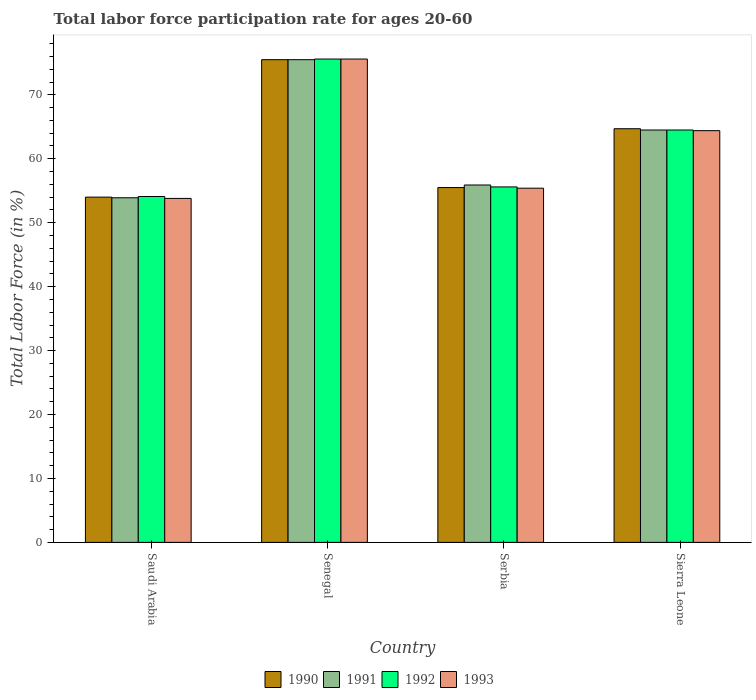How many different coloured bars are there?
Ensure brevity in your answer.  4. How many bars are there on the 1st tick from the right?
Make the answer very short. 4. What is the label of the 3rd group of bars from the left?
Give a very brief answer. Serbia. Across all countries, what is the maximum labor force participation rate in 1991?
Provide a succinct answer. 75.5. Across all countries, what is the minimum labor force participation rate in 1992?
Give a very brief answer. 54.1. In which country was the labor force participation rate in 1992 maximum?
Your answer should be compact. Senegal. In which country was the labor force participation rate in 1990 minimum?
Your response must be concise. Saudi Arabia. What is the total labor force participation rate in 1990 in the graph?
Your answer should be very brief. 249.7. What is the difference between the labor force participation rate in 1993 in Senegal and that in Serbia?
Your answer should be very brief. 20.2. What is the difference between the labor force participation rate in 1991 in Saudi Arabia and the labor force participation rate in 1993 in Sierra Leone?
Your answer should be compact. -10.5. What is the average labor force participation rate in 1993 per country?
Provide a short and direct response. 62.3. What is the difference between the labor force participation rate of/in 1992 and labor force participation rate of/in 1990 in Serbia?
Provide a succinct answer. 0.1. In how many countries, is the labor force participation rate in 1993 greater than 14 %?
Your answer should be very brief. 4. What is the ratio of the labor force participation rate in 1991 in Serbia to that in Sierra Leone?
Give a very brief answer. 0.87. Is the labor force participation rate in 1993 in Serbia less than that in Sierra Leone?
Offer a very short reply. Yes. What is the difference between the highest and the second highest labor force participation rate in 1992?
Offer a very short reply. -11.1. What is the difference between the highest and the lowest labor force participation rate in 1991?
Make the answer very short. 21.6. Is the sum of the labor force participation rate in 1993 in Saudi Arabia and Serbia greater than the maximum labor force participation rate in 1990 across all countries?
Give a very brief answer. Yes. Is it the case that in every country, the sum of the labor force participation rate in 1991 and labor force participation rate in 1993 is greater than the sum of labor force participation rate in 1990 and labor force participation rate in 1992?
Your answer should be compact. No. What does the 2nd bar from the left in Serbia represents?
Give a very brief answer. 1991. What does the 2nd bar from the right in Sierra Leone represents?
Provide a short and direct response. 1992. Is it the case that in every country, the sum of the labor force participation rate in 1990 and labor force participation rate in 1993 is greater than the labor force participation rate in 1991?
Make the answer very short. Yes. How many countries are there in the graph?
Keep it short and to the point. 4. What is the difference between two consecutive major ticks on the Y-axis?
Keep it short and to the point. 10. Are the values on the major ticks of Y-axis written in scientific E-notation?
Provide a succinct answer. No. Does the graph contain any zero values?
Your response must be concise. No. Does the graph contain grids?
Provide a succinct answer. No. What is the title of the graph?
Offer a very short reply. Total labor force participation rate for ages 20-60. What is the label or title of the X-axis?
Keep it short and to the point. Country. What is the label or title of the Y-axis?
Your response must be concise. Total Labor Force (in %). What is the Total Labor Force (in %) in 1991 in Saudi Arabia?
Offer a very short reply. 53.9. What is the Total Labor Force (in %) in 1992 in Saudi Arabia?
Give a very brief answer. 54.1. What is the Total Labor Force (in %) in 1993 in Saudi Arabia?
Keep it short and to the point. 53.8. What is the Total Labor Force (in %) of 1990 in Senegal?
Make the answer very short. 75.5. What is the Total Labor Force (in %) of 1991 in Senegal?
Give a very brief answer. 75.5. What is the Total Labor Force (in %) of 1992 in Senegal?
Your answer should be compact. 75.6. What is the Total Labor Force (in %) in 1993 in Senegal?
Offer a terse response. 75.6. What is the Total Labor Force (in %) in 1990 in Serbia?
Your response must be concise. 55.5. What is the Total Labor Force (in %) of 1991 in Serbia?
Make the answer very short. 55.9. What is the Total Labor Force (in %) of 1992 in Serbia?
Give a very brief answer. 55.6. What is the Total Labor Force (in %) in 1993 in Serbia?
Offer a terse response. 55.4. What is the Total Labor Force (in %) in 1990 in Sierra Leone?
Your answer should be very brief. 64.7. What is the Total Labor Force (in %) in 1991 in Sierra Leone?
Offer a terse response. 64.5. What is the Total Labor Force (in %) in 1992 in Sierra Leone?
Your answer should be very brief. 64.5. What is the Total Labor Force (in %) in 1993 in Sierra Leone?
Your response must be concise. 64.4. Across all countries, what is the maximum Total Labor Force (in %) of 1990?
Offer a terse response. 75.5. Across all countries, what is the maximum Total Labor Force (in %) in 1991?
Your answer should be compact. 75.5. Across all countries, what is the maximum Total Labor Force (in %) of 1992?
Offer a very short reply. 75.6. Across all countries, what is the maximum Total Labor Force (in %) in 1993?
Your answer should be compact. 75.6. Across all countries, what is the minimum Total Labor Force (in %) of 1990?
Your response must be concise. 54. Across all countries, what is the minimum Total Labor Force (in %) in 1991?
Keep it short and to the point. 53.9. Across all countries, what is the minimum Total Labor Force (in %) of 1992?
Give a very brief answer. 54.1. Across all countries, what is the minimum Total Labor Force (in %) in 1993?
Provide a succinct answer. 53.8. What is the total Total Labor Force (in %) in 1990 in the graph?
Keep it short and to the point. 249.7. What is the total Total Labor Force (in %) of 1991 in the graph?
Make the answer very short. 249.8. What is the total Total Labor Force (in %) in 1992 in the graph?
Your response must be concise. 249.8. What is the total Total Labor Force (in %) in 1993 in the graph?
Your response must be concise. 249.2. What is the difference between the Total Labor Force (in %) in 1990 in Saudi Arabia and that in Senegal?
Your response must be concise. -21.5. What is the difference between the Total Labor Force (in %) of 1991 in Saudi Arabia and that in Senegal?
Offer a very short reply. -21.6. What is the difference between the Total Labor Force (in %) in 1992 in Saudi Arabia and that in Senegal?
Your answer should be compact. -21.5. What is the difference between the Total Labor Force (in %) in 1993 in Saudi Arabia and that in Senegal?
Provide a succinct answer. -21.8. What is the difference between the Total Labor Force (in %) of 1992 in Saudi Arabia and that in Serbia?
Give a very brief answer. -1.5. What is the difference between the Total Labor Force (in %) of 1993 in Saudi Arabia and that in Serbia?
Give a very brief answer. -1.6. What is the difference between the Total Labor Force (in %) in 1990 in Saudi Arabia and that in Sierra Leone?
Make the answer very short. -10.7. What is the difference between the Total Labor Force (in %) of 1992 in Saudi Arabia and that in Sierra Leone?
Provide a succinct answer. -10.4. What is the difference between the Total Labor Force (in %) in 1990 in Senegal and that in Serbia?
Your answer should be compact. 20. What is the difference between the Total Labor Force (in %) in 1991 in Senegal and that in Serbia?
Keep it short and to the point. 19.6. What is the difference between the Total Labor Force (in %) of 1992 in Senegal and that in Serbia?
Keep it short and to the point. 20. What is the difference between the Total Labor Force (in %) in 1993 in Senegal and that in Serbia?
Ensure brevity in your answer.  20.2. What is the difference between the Total Labor Force (in %) in 1990 in Senegal and that in Sierra Leone?
Offer a very short reply. 10.8. What is the difference between the Total Labor Force (in %) of 1992 in Senegal and that in Sierra Leone?
Offer a terse response. 11.1. What is the difference between the Total Labor Force (in %) of 1991 in Serbia and that in Sierra Leone?
Offer a terse response. -8.6. What is the difference between the Total Labor Force (in %) of 1992 in Serbia and that in Sierra Leone?
Your answer should be compact. -8.9. What is the difference between the Total Labor Force (in %) of 1993 in Serbia and that in Sierra Leone?
Keep it short and to the point. -9. What is the difference between the Total Labor Force (in %) in 1990 in Saudi Arabia and the Total Labor Force (in %) in 1991 in Senegal?
Give a very brief answer. -21.5. What is the difference between the Total Labor Force (in %) in 1990 in Saudi Arabia and the Total Labor Force (in %) in 1992 in Senegal?
Ensure brevity in your answer.  -21.6. What is the difference between the Total Labor Force (in %) of 1990 in Saudi Arabia and the Total Labor Force (in %) of 1993 in Senegal?
Give a very brief answer. -21.6. What is the difference between the Total Labor Force (in %) in 1991 in Saudi Arabia and the Total Labor Force (in %) in 1992 in Senegal?
Ensure brevity in your answer.  -21.7. What is the difference between the Total Labor Force (in %) in 1991 in Saudi Arabia and the Total Labor Force (in %) in 1993 in Senegal?
Your response must be concise. -21.7. What is the difference between the Total Labor Force (in %) in 1992 in Saudi Arabia and the Total Labor Force (in %) in 1993 in Senegal?
Your response must be concise. -21.5. What is the difference between the Total Labor Force (in %) in 1990 in Saudi Arabia and the Total Labor Force (in %) in 1992 in Serbia?
Your answer should be compact. -1.6. What is the difference between the Total Labor Force (in %) in 1990 in Saudi Arabia and the Total Labor Force (in %) in 1993 in Serbia?
Keep it short and to the point. -1.4. What is the difference between the Total Labor Force (in %) of 1991 in Saudi Arabia and the Total Labor Force (in %) of 1993 in Serbia?
Your response must be concise. -1.5. What is the difference between the Total Labor Force (in %) of 1992 in Saudi Arabia and the Total Labor Force (in %) of 1993 in Serbia?
Give a very brief answer. -1.3. What is the difference between the Total Labor Force (in %) in 1990 in Saudi Arabia and the Total Labor Force (in %) in 1993 in Sierra Leone?
Provide a short and direct response. -10.4. What is the difference between the Total Labor Force (in %) of 1991 in Saudi Arabia and the Total Labor Force (in %) of 1992 in Sierra Leone?
Offer a terse response. -10.6. What is the difference between the Total Labor Force (in %) of 1992 in Saudi Arabia and the Total Labor Force (in %) of 1993 in Sierra Leone?
Your answer should be compact. -10.3. What is the difference between the Total Labor Force (in %) in 1990 in Senegal and the Total Labor Force (in %) in 1991 in Serbia?
Offer a terse response. 19.6. What is the difference between the Total Labor Force (in %) of 1990 in Senegal and the Total Labor Force (in %) of 1993 in Serbia?
Provide a short and direct response. 20.1. What is the difference between the Total Labor Force (in %) of 1991 in Senegal and the Total Labor Force (in %) of 1993 in Serbia?
Keep it short and to the point. 20.1. What is the difference between the Total Labor Force (in %) in 1992 in Senegal and the Total Labor Force (in %) in 1993 in Serbia?
Your response must be concise. 20.2. What is the difference between the Total Labor Force (in %) of 1990 in Senegal and the Total Labor Force (in %) of 1991 in Sierra Leone?
Keep it short and to the point. 11. What is the difference between the Total Labor Force (in %) in 1991 in Senegal and the Total Labor Force (in %) in 1993 in Sierra Leone?
Your answer should be compact. 11.1. What is the difference between the Total Labor Force (in %) in 1990 in Serbia and the Total Labor Force (in %) in 1993 in Sierra Leone?
Offer a terse response. -8.9. What is the difference between the Total Labor Force (in %) of 1991 in Serbia and the Total Labor Force (in %) of 1992 in Sierra Leone?
Provide a succinct answer. -8.6. What is the average Total Labor Force (in %) in 1990 per country?
Your answer should be compact. 62.42. What is the average Total Labor Force (in %) in 1991 per country?
Give a very brief answer. 62.45. What is the average Total Labor Force (in %) in 1992 per country?
Offer a very short reply. 62.45. What is the average Total Labor Force (in %) in 1993 per country?
Make the answer very short. 62.3. What is the difference between the Total Labor Force (in %) in 1990 and Total Labor Force (in %) in 1991 in Saudi Arabia?
Give a very brief answer. 0.1. What is the difference between the Total Labor Force (in %) of 1990 and Total Labor Force (in %) of 1992 in Saudi Arabia?
Offer a terse response. -0.1. What is the difference between the Total Labor Force (in %) of 1990 and Total Labor Force (in %) of 1993 in Saudi Arabia?
Provide a short and direct response. 0.2. What is the difference between the Total Labor Force (in %) of 1991 and Total Labor Force (in %) of 1993 in Saudi Arabia?
Offer a very short reply. 0.1. What is the difference between the Total Labor Force (in %) of 1990 and Total Labor Force (in %) of 1991 in Senegal?
Give a very brief answer. 0. What is the difference between the Total Labor Force (in %) in 1992 and Total Labor Force (in %) in 1993 in Senegal?
Your answer should be very brief. 0. What is the difference between the Total Labor Force (in %) of 1990 and Total Labor Force (in %) of 1991 in Serbia?
Offer a very short reply. -0.4. What is the difference between the Total Labor Force (in %) in 1990 and Total Labor Force (in %) in 1992 in Serbia?
Give a very brief answer. -0.1. What is the difference between the Total Labor Force (in %) of 1990 and Total Labor Force (in %) of 1993 in Serbia?
Offer a very short reply. 0.1. What is the difference between the Total Labor Force (in %) in 1991 and Total Labor Force (in %) in 1992 in Serbia?
Provide a short and direct response. 0.3. What is the difference between the Total Labor Force (in %) of 1991 and Total Labor Force (in %) of 1993 in Serbia?
Ensure brevity in your answer.  0.5. What is the difference between the Total Labor Force (in %) in 1992 and Total Labor Force (in %) in 1993 in Serbia?
Provide a short and direct response. 0.2. What is the difference between the Total Labor Force (in %) in 1990 and Total Labor Force (in %) in 1992 in Sierra Leone?
Your response must be concise. 0.2. What is the difference between the Total Labor Force (in %) in 1991 and Total Labor Force (in %) in 1993 in Sierra Leone?
Provide a short and direct response. 0.1. What is the difference between the Total Labor Force (in %) of 1992 and Total Labor Force (in %) of 1993 in Sierra Leone?
Your answer should be very brief. 0.1. What is the ratio of the Total Labor Force (in %) of 1990 in Saudi Arabia to that in Senegal?
Your answer should be compact. 0.72. What is the ratio of the Total Labor Force (in %) of 1991 in Saudi Arabia to that in Senegal?
Your answer should be very brief. 0.71. What is the ratio of the Total Labor Force (in %) of 1992 in Saudi Arabia to that in Senegal?
Your answer should be very brief. 0.72. What is the ratio of the Total Labor Force (in %) in 1993 in Saudi Arabia to that in Senegal?
Your answer should be very brief. 0.71. What is the ratio of the Total Labor Force (in %) in 1990 in Saudi Arabia to that in Serbia?
Offer a terse response. 0.97. What is the ratio of the Total Labor Force (in %) in 1991 in Saudi Arabia to that in Serbia?
Ensure brevity in your answer.  0.96. What is the ratio of the Total Labor Force (in %) in 1992 in Saudi Arabia to that in Serbia?
Keep it short and to the point. 0.97. What is the ratio of the Total Labor Force (in %) in 1993 in Saudi Arabia to that in Serbia?
Your answer should be very brief. 0.97. What is the ratio of the Total Labor Force (in %) of 1990 in Saudi Arabia to that in Sierra Leone?
Your answer should be compact. 0.83. What is the ratio of the Total Labor Force (in %) of 1991 in Saudi Arabia to that in Sierra Leone?
Your answer should be compact. 0.84. What is the ratio of the Total Labor Force (in %) in 1992 in Saudi Arabia to that in Sierra Leone?
Ensure brevity in your answer.  0.84. What is the ratio of the Total Labor Force (in %) of 1993 in Saudi Arabia to that in Sierra Leone?
Provide a short and direct response. 0.84. What is the ratio of the Total Labor Force (in %) of 1990 in Senegal to that in Serbia?
Provide a short and direct response. 1.36. What is the ratio of the Total Labor Force (in %) of 1991 in Senegal to that in Serbia?
Your answer should be very brief. 1.35. What is the ratio of the Total Labor Force (in %) in 1992 in Senegal to that in Serbia?
Provide a short and direct response. 1.36. What is the ratio of the Total Labor Force (in %) of 1993 in Senegal to that in Serbia?
Your response must be concise. 1.36. What is the ratio of the Total Labor Force (in %) in 1990 in Senegal to that in Sierra Leone?
Keep it short and to the point. 1.17. What is the ratio of the Total Labor Force (in %) of 1991 in Senegal to that in Sierra Leone?
Provide a short and direct response. 1.17. What is the ratio of the Total Labor Force (in %) in 1992 in Senegal to that in Sierra Leone?
Offer a very short reply. 1.17. What is the ratio of the Total Labor Force (in %) of 1993 in Senegal to that in Sierra Leone?
Your answer should be compact. 1.17. What is the ratio of the Total Labor Force (in %) of 1990 in Serbia to that in Sierra Leone?
Your answer should be very brief. 0.86. What is the ratio of the Total Labor Force (in %) in 1991 in Serbia to that in Sierra Leone?
Keep it short and to the point. 0.87. What is the ratio of the Total Labor Force (in %) of 1992 in Serbia to that in Sierra Leone?
Provide a succinct answer. 0.86. What is the ratio of the Total Labor Force (in %) in 1993 in Serbia to that in Sierra Leone?
Make the answer very short. 0.86. What is the difference between the highest and the second highest Total Labor Force (in %) of 1991?
Make the answer very short. 11. What is the difference between the highest and the second highest Total Labor Force (in %) in 1993?
Keep it short and to the point. 11.2. What is the difference between the highest and the lowest Total Labor Force (in %) of 1991?
Give a very brief answer. 21.6. What is the difference between the highest and the lowest Total Labor Force (in %) of 1992?
Offer a very short reply. 21.5. What is the difference between the highest and the lowest Total Labor Force (in %) in 1993?
Ensure brevity in your answer.  21.8. 